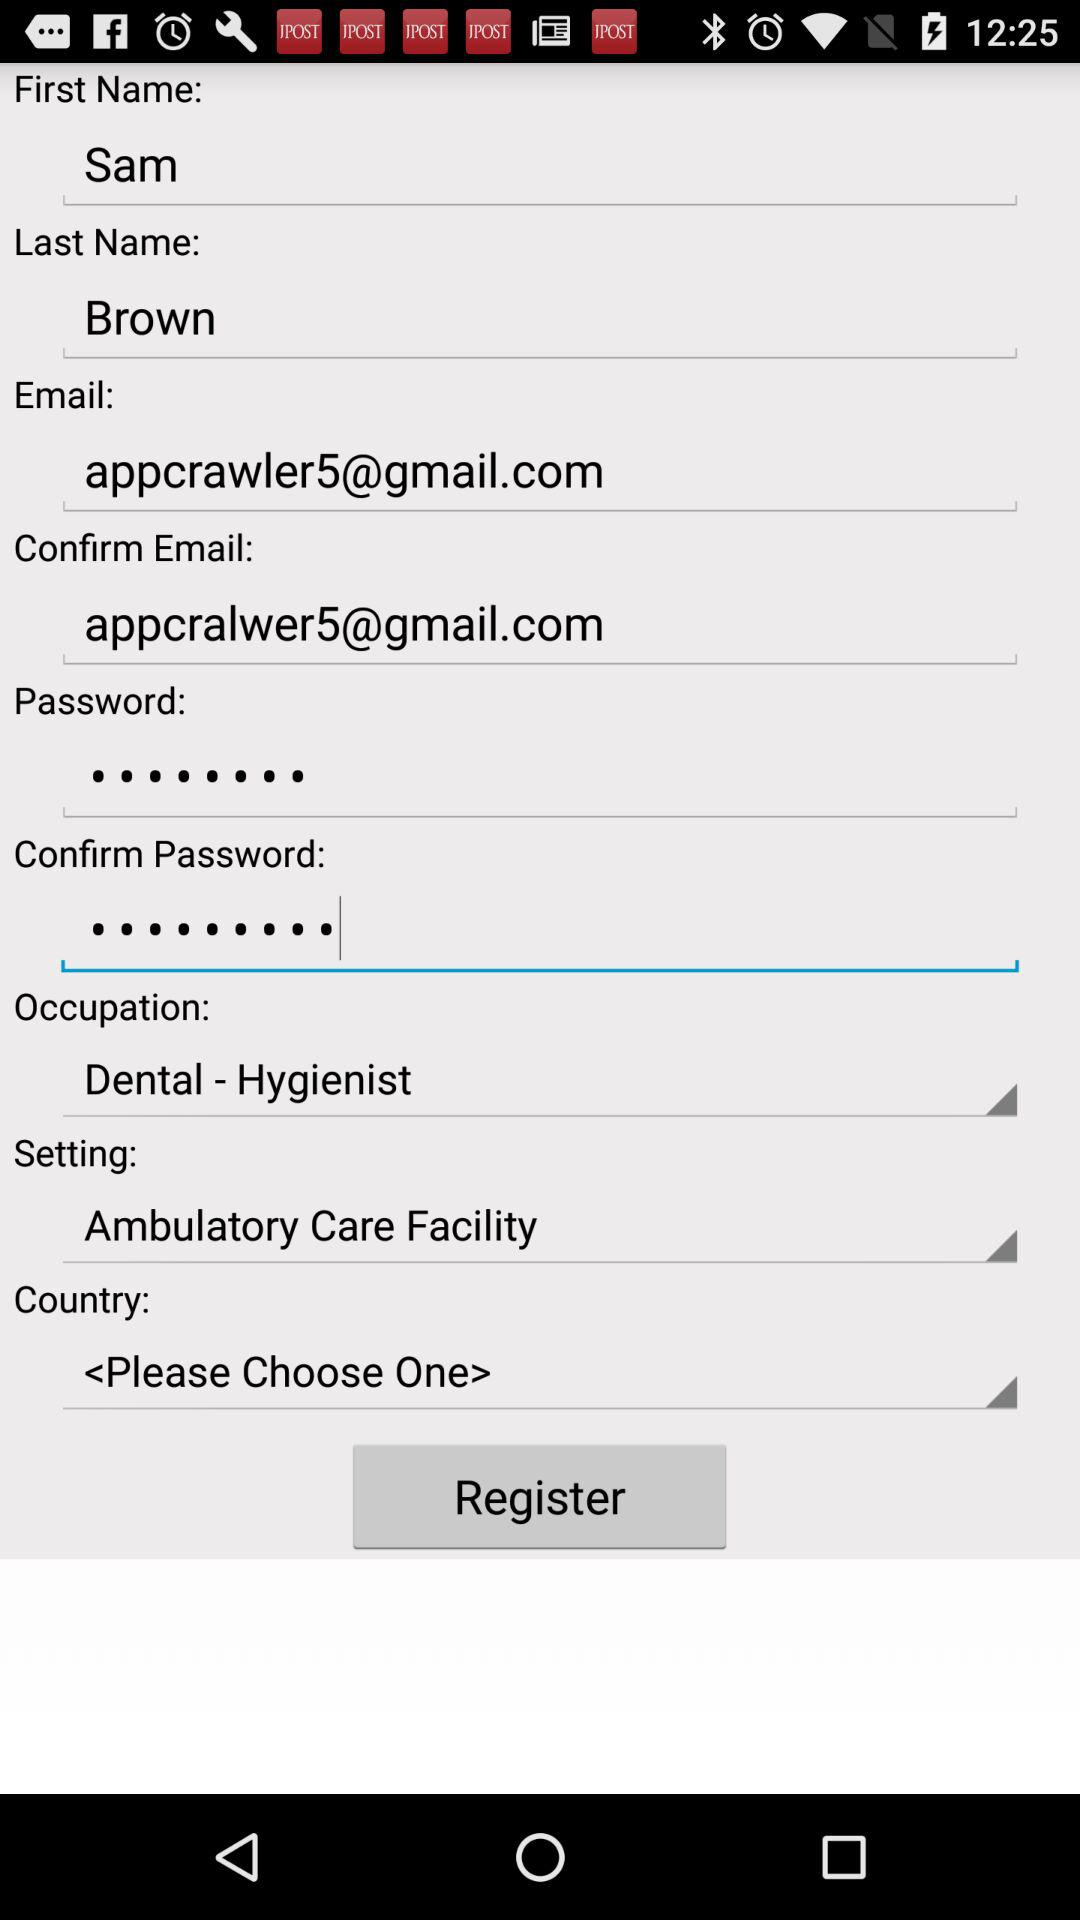How many text inputs have an email address?
Answer the question using a single word or phrase. 2 